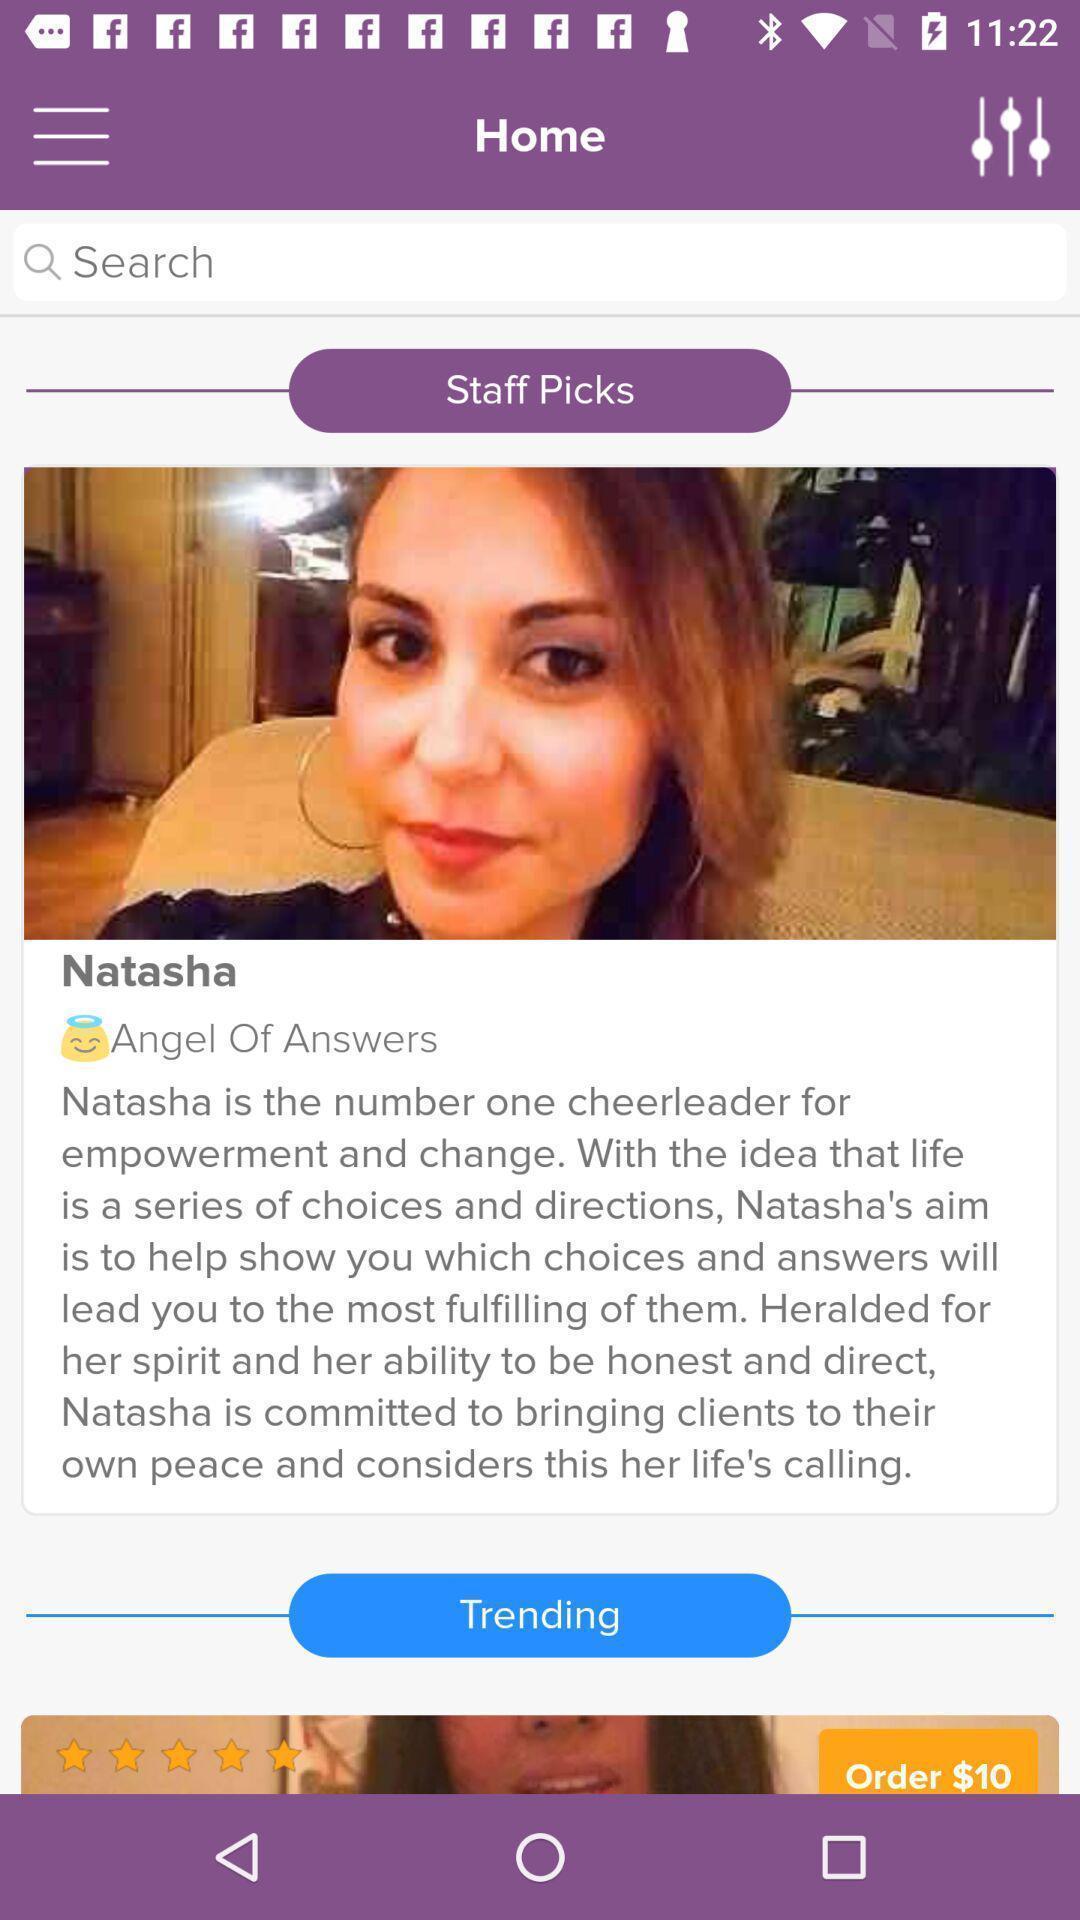What is the overall content of this screenshot? Page showing search bar to find different people. 